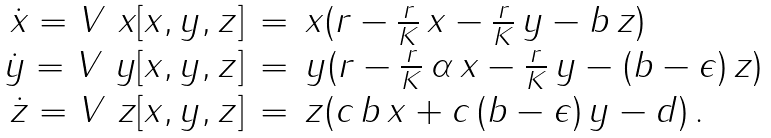Convert formula to latex. <formula><loc_0><loc_0><loc_500><loc_500>\begin{array} { r c l } \dot { x } = V \ { x } [ x , y , z ] & = & x ( r - \frac { r } { K } \, x - \frac { r } { K } \, y - b \, z ) \\ \dot { y } = V \ { y } [ x , y , z ] & = & y ( r - \frac { r } { K } \, \alpha \, x - \frac { r } { K } \, y - ( b - \epsilon ) \, z ) \\ \dot { z } = V \ { z } [ x , y , z ] & = & z ( c \, b \, x + c \, ( b - \epsilon ) \, y - d ) \, . \ \end{array}</formula> 